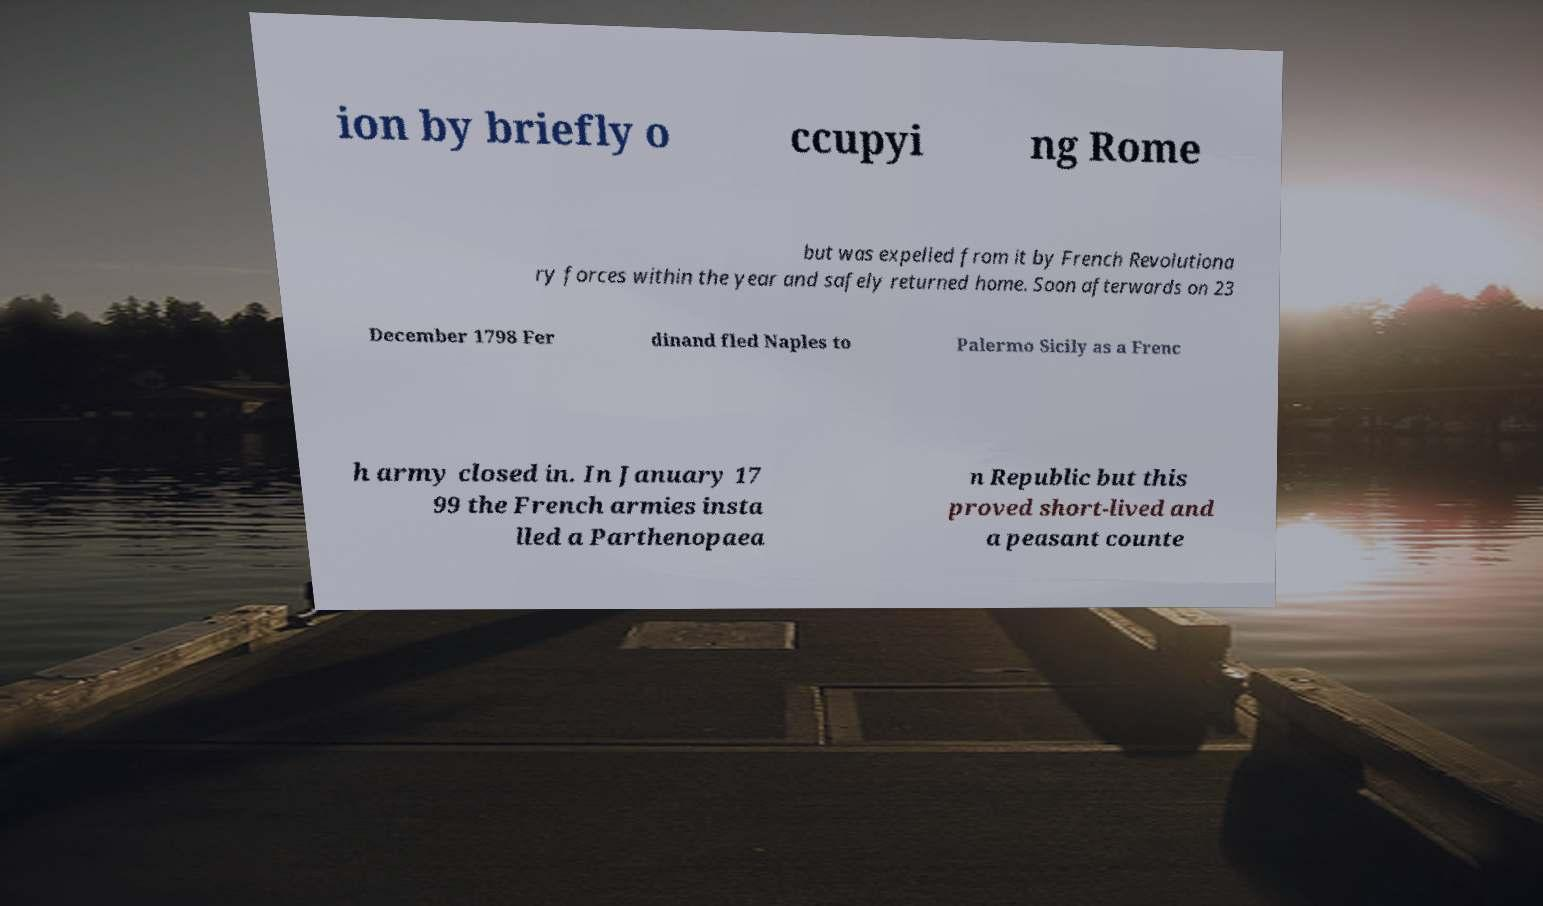Can you accurately transcribe the text from the provided image for me? ion by briefly o ccupyi ng Rome but was expelled from it by French Revolutiona ry forces within the year and safely returned home. Soon afterwards on 23 December 1798 Fer dinand fled Naples to Palermo Sicily as a Frenc h army closed in. In January 17 99 the French armies insta lled a Parthenopaea n Republic but this proved short-lived and a peasant counte 